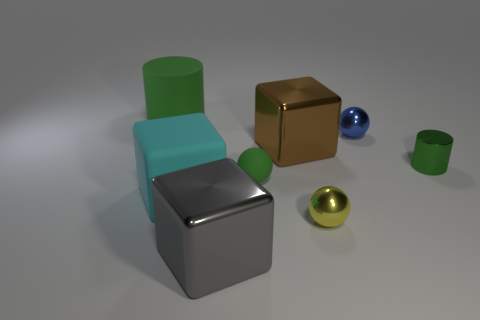Subtract all big cyan matte cubes. How many cubes are left? 2 Add 2 yellow cubes. How many objects exist? 10 Subtract all spheres. How many objects are left? 5 Add 5 tiny blue shiny spheres. How many tiny blue shiny spheres exist? 6 Subtract 0 blue cylinders. How many objects are left? 8 Subtract all shiny balls. Subtract all large brown shiny things. How many objects are left? 5 Add 5 metallic cylinders. How many metallic cylinders are left? 6 